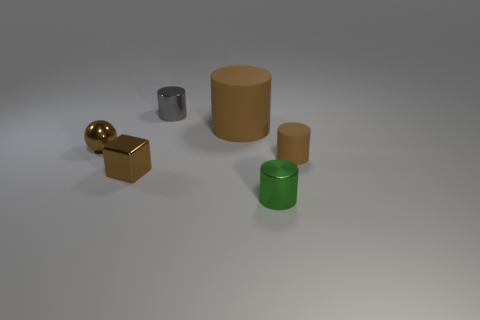Is there a thing that has the same color as the cube?
Ensure brevity in your answer.  Yes. What size is the metallic block that is the same color as the ball?
Your answer should be very brief. Small. There is a small thing on the right side of the small green cylinder; does it have the same color as the small thing to the left of the brown cube?
Provide a succinct answer. Yes. There is a rubber object that is the same color as the large cylinder; what shape is it?
Ensure brevity in your answer.  Cylinder. Is there any other thing that has the same color as the tiny metal block?
Your answer should be compact. Yes. How many other objects are there of the same material as the small cube?
Make the answer very short. 3. There is a rubber cylinder to the left of the small brown matte cylinder; is its size the same as the block to the left of the small rubber cylinder?
Provide a succinct answer. No. Is there a brown ball of the same size as the green cylinder?
Offer a terse response. Yes. There is a tiny shiny thing that is to the right of the big matte object; how many small shiny cylinders are behind it?
Offer a terse response. 1. What material is the small sphere?
Give a very brief answer. Metal. 